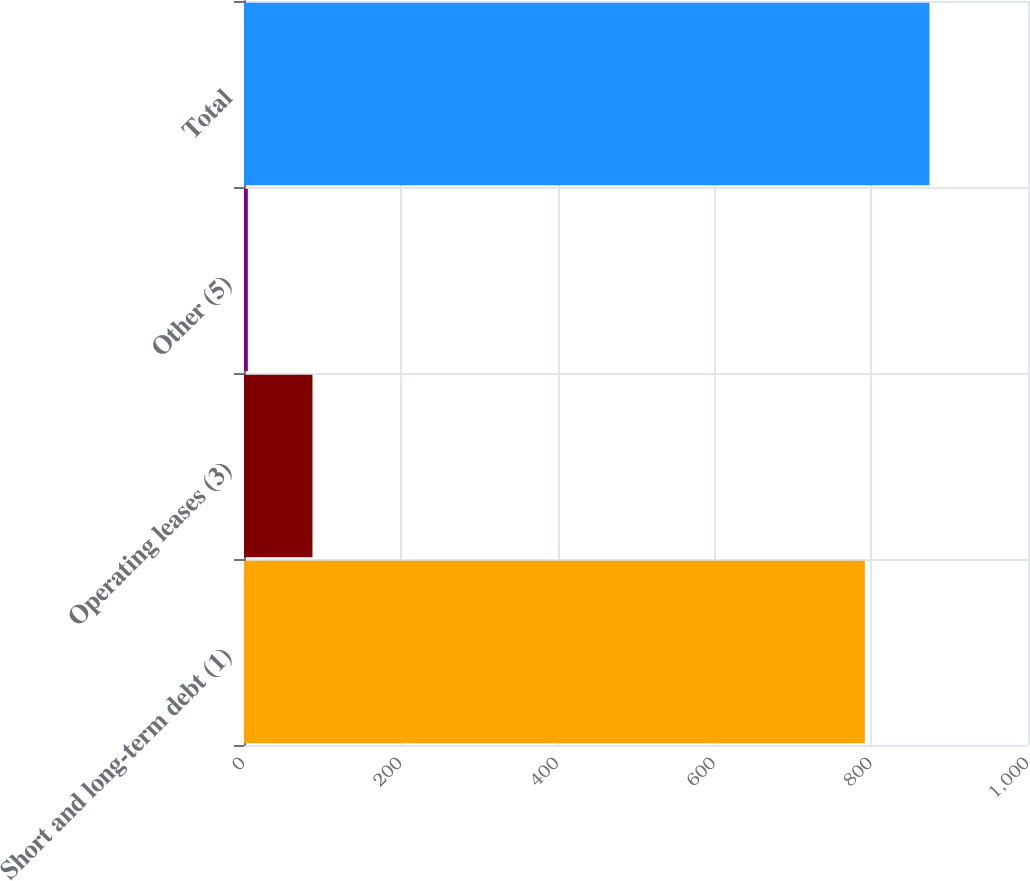Convert chart. <chart><loc_0><loc_0><loc_500><loc_500><bar_chart><fcel>Short and long-term debt (1)<fcel>Operating leases (3)<fcel>Other (5)<fcel>Total<nl><fcel>791.9<fcel>87.33<fcel>4.9<fcel>874.33<nl></chart> 